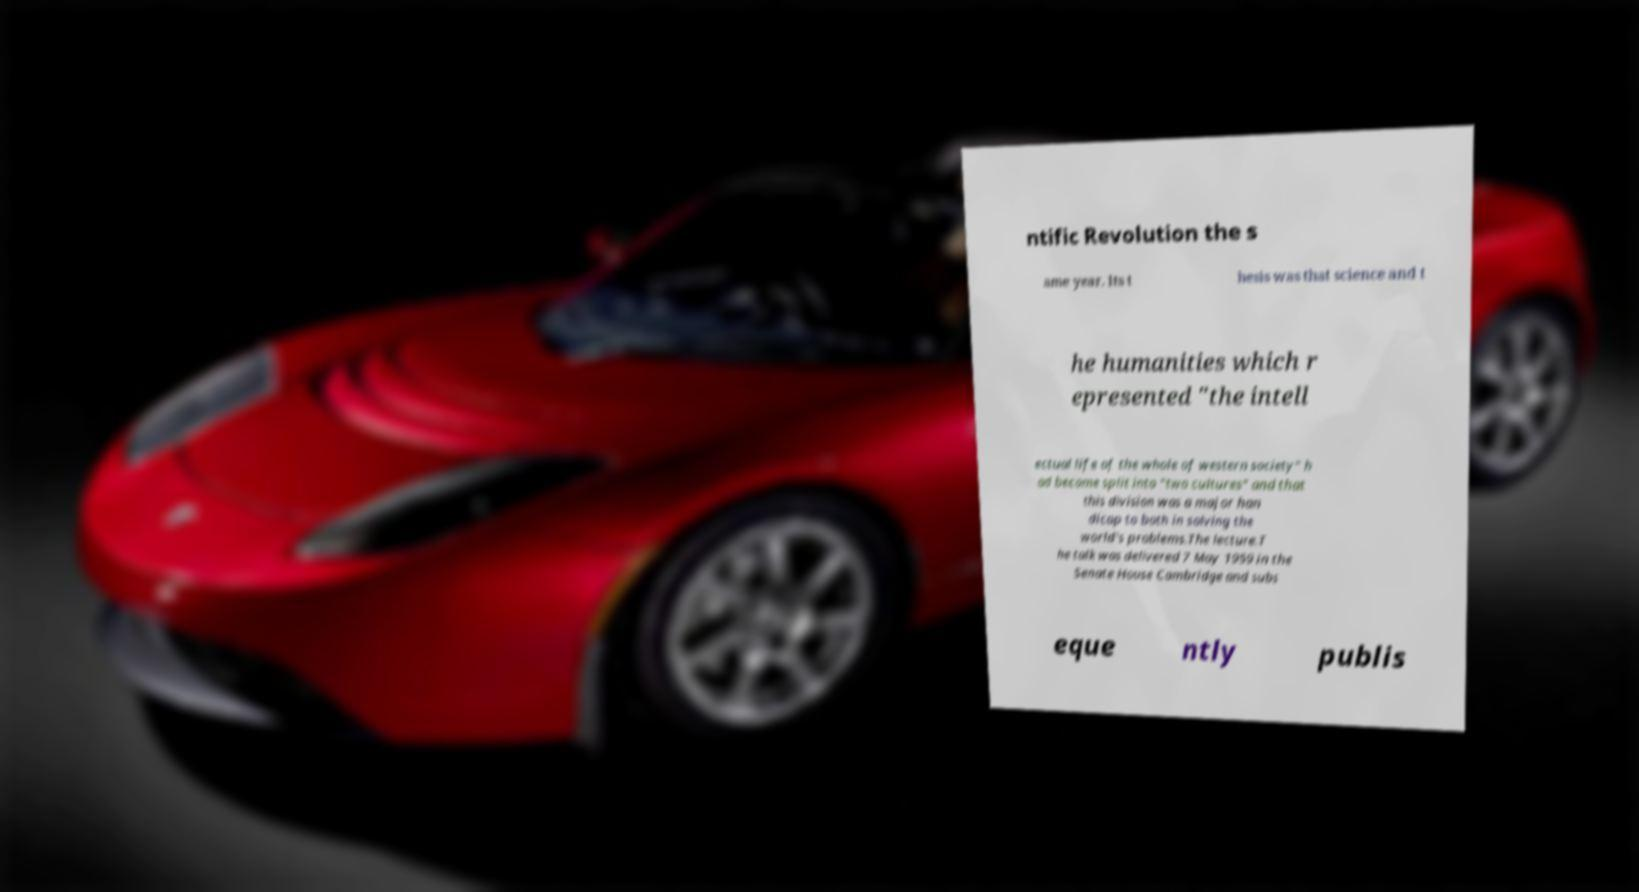What messages or text are displayed in this image? I need them in a readable, typed format. ntific Revolution the s ame year. Its t hesis was that science and t he humanities which r epresented "the intell ectual life of the whole of western society" h ad become split into "two cultures" and that this division was a major han dicap to both in solving the world's problems.The lecture.T he talk was delivered 7 May 1959 in the Senate House Cambridge and subs eque ntly publis 